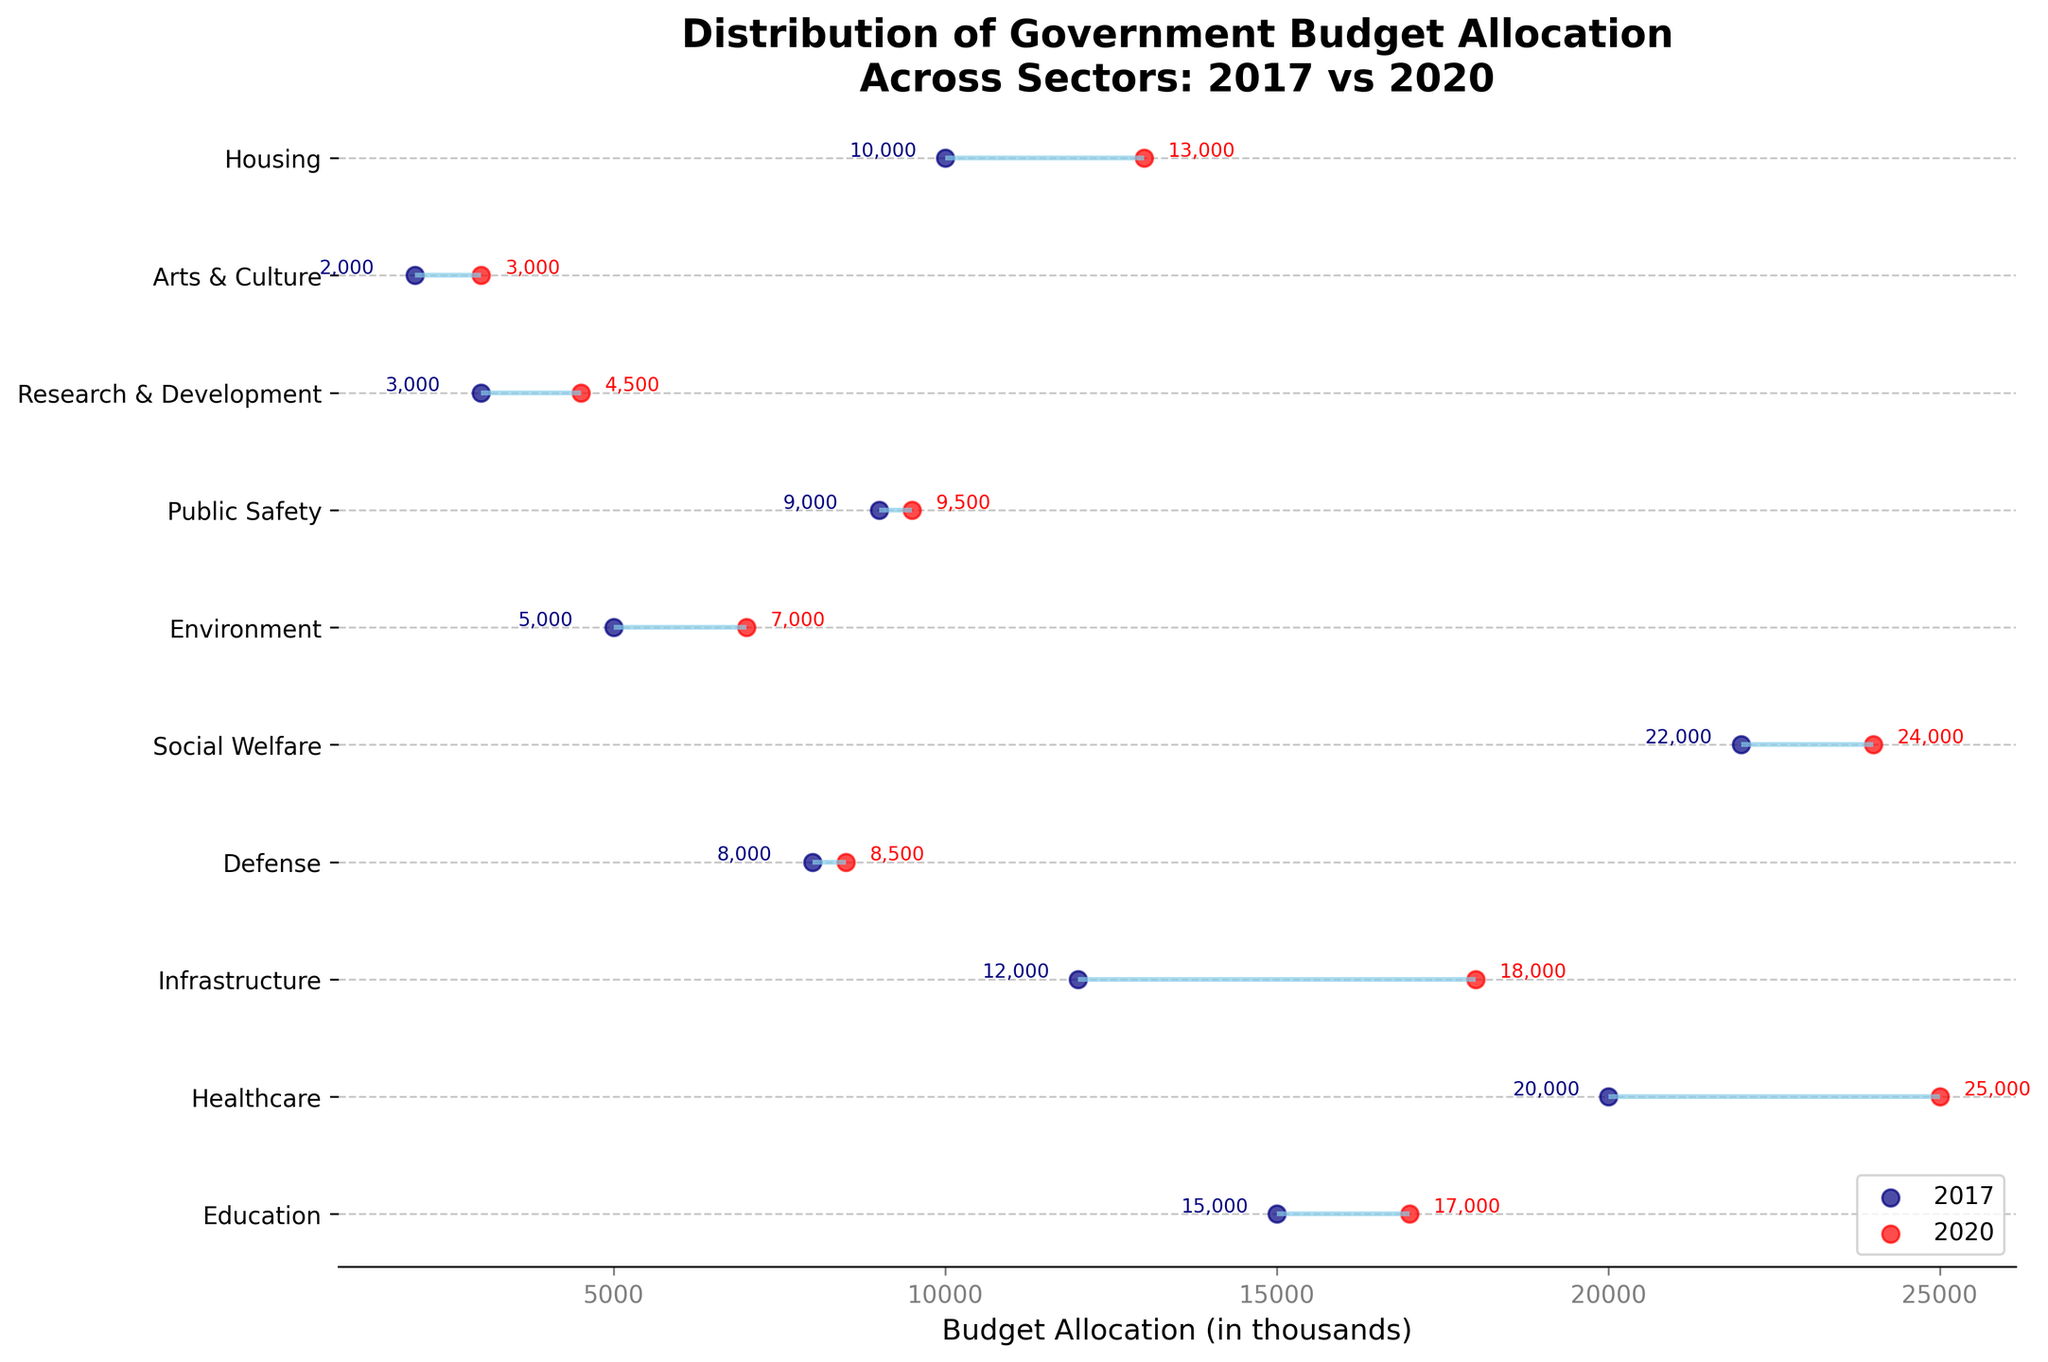What is the total budget allocated to Education in 2017? In 2017, the plot shows a navy blue dot aligned with the 'Education' sector corresponding to the budget allocation value.
Answer: 15,000 How much did the budget for Healthcare increase from 2017 to 2020? The budget for Healthcare in 2017 is indicated as 20,000, and in 2020 it is 25,000. The increase is the difference between these two values: 25,000 - 20,000 = 5,000.
Answer: 5,000 Which sector saw the highest budget increase between 2017 and 2020? To find the highest increase, look at the difference between the two years for all sectors. Infrastructure has the largest increase, from 12,000 in 2017 to 18,000 in 2020, which is an increase of 6,000.
Answer: Infrastructure Is there any sector where the budget allocation decreased from 2017 to 2020? All sectors in the Dumbbell Plot show an increase, as the red dots (2020) are always to the right of the navy blue dots (2017).
Answer: No What is the budget allocation for Defense in 2020? The plot shows a red dot corresponding to the budget allocation for Defense in 2020, which is labeled as 8,500.
Answer: 8,500 Compare the budget allocations for Public Safety and Housing in 2020. Which is higher? In 2020, the red dots show Public Safety at 9,500 and Housing at 13,000. Housing has a higher budget allocation.
Answer: Housing Which sector received the lowest budget allocation in both years? By checking the plot, Arts & Culture has the smallest budget allocation in both 2017 (2,000) and 2020 (3,000).
Answer: Arts & Culture What is the average budget allocation change across all sectors from 2017 to 2020? Calculate each sector's increase and then average these increases. (Education: 2,000, Healthcare: 5,000, Infrastructure: 6,000, Defense: 500, Social Welfare: 2,000, Environment: 2,000, Public Safety: 500, Research & Development: 1,500, Arts & Culture: 1,000, Housing: 3,000). Sum of increases: 23,500. Divide by 10 sectors: 23,500 / 10 = 2,350.
Answer: 2,350 